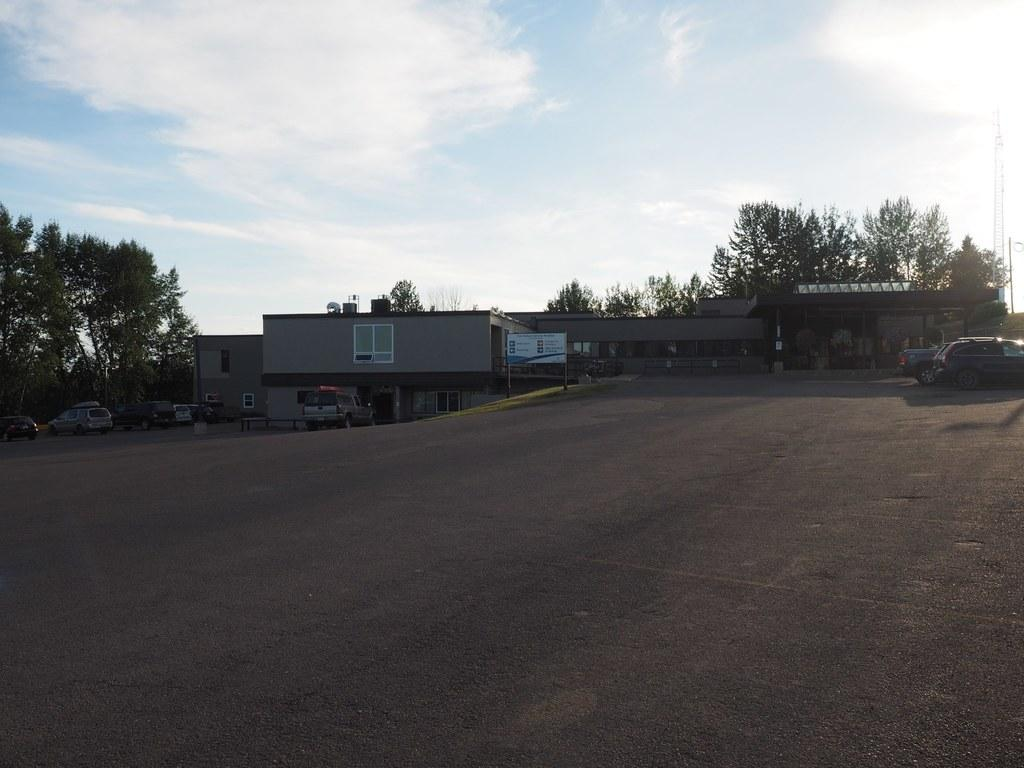What is happening on the road in the image? There are vehicles on the road in the image. What can be seen on the grassland in the image? There is a board with poles on the grassland in the image. What type of structure is present in the image? There is a building in the image. What is located behind the building in the image? There are trees behind the building in the image. What is visible at the top of the image? The sky is visible at the top of the image. What type of crime is being committed in the image? There is no indication of any crime being committed in the image. What treatment is being administered to the trees behind the building? There is no treatment being administered to the trees in the image; they are simply visible in the background. 